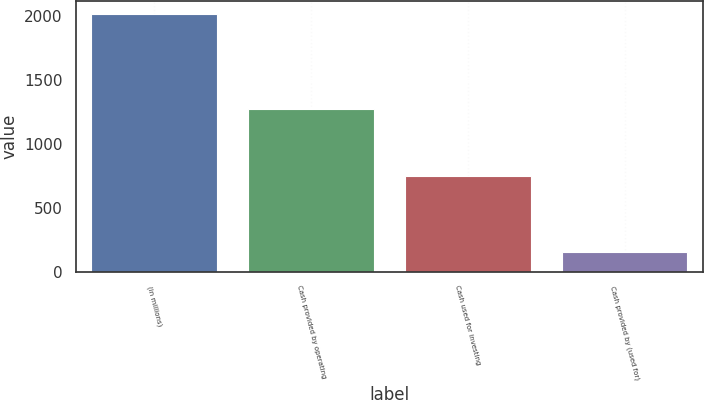Convert chart to OTSL. <chart><loc_0><loc_0><loc_500><loc_500><bar_chart><fcel>(in millions)<fcel>Cash provided by operating<fcel>Cash used for investing<fcel>Cash provided by (used for)<nl><fcel>2014<fcel>1269<fcel>745<fcel>150<nl></chart> 